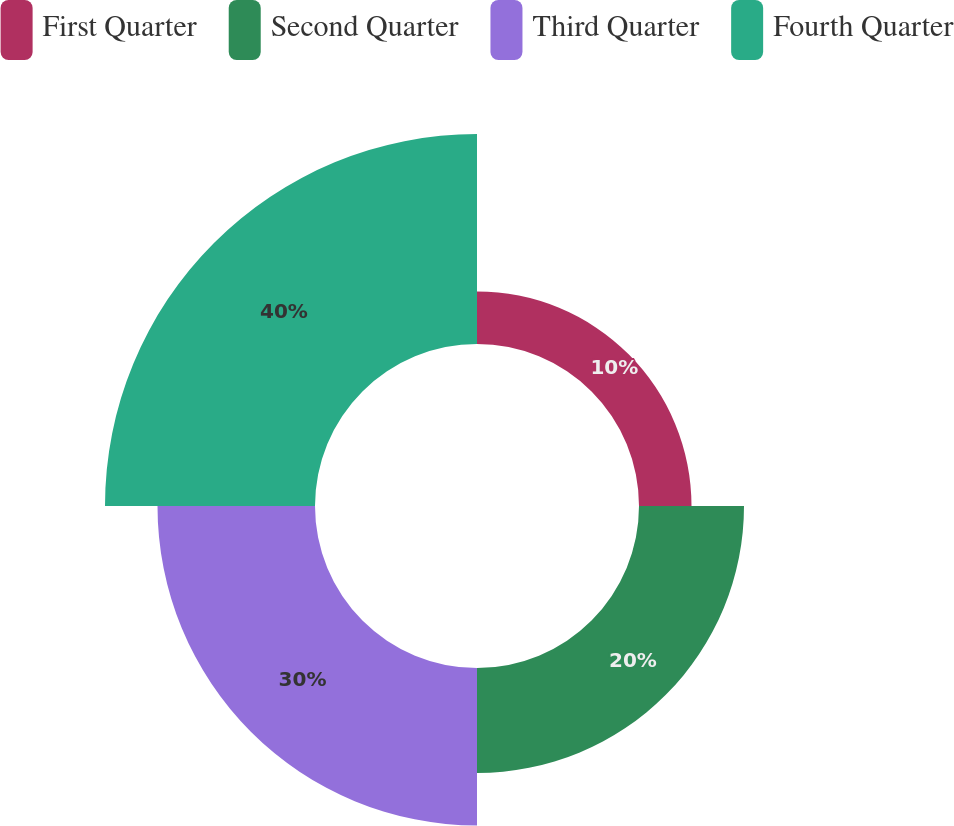<chart> <loc_0><loc_0><loc_500><loc_500><pie_chart><fcel>First Quarter<fcel>Second Quarter<fcel>Third Quarter<fcel>Fourth Quarter<nl><fcel>10.0%<fcel>20.0%<fcel>30.0%<fcel>40.0%<nl></chart> 